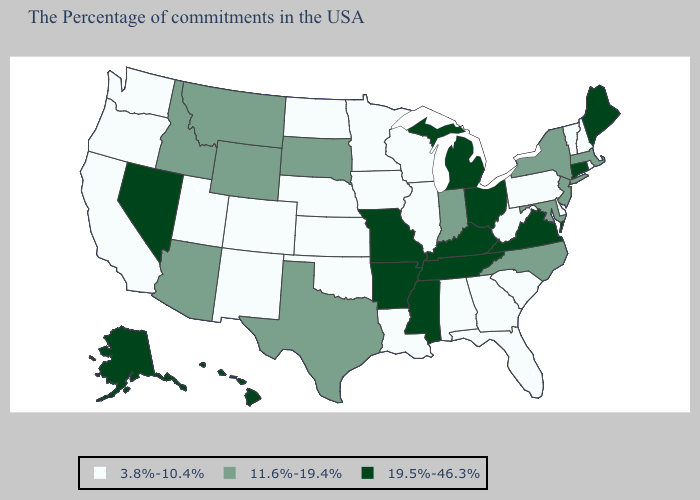Does the first symbol in the legend represent the smallest category?
Concise answer only. Yes. Does South Carolina have the highest value in the USA?
Answer briefly. No. How many symbols are there in the legend?
Keep it brief. 3. What is the highest value in the Northeast ?
Keep it brief. 19.5%-46.3%. Does Michigan have the highest value in the USA?
Answer briefly. Yes. What is the value of Illinois?
Quick response, please. 3.8%-10.4%. Name the states that have a value in the range 19.5%-46.3%?
Short answer required. Maine, Connecticut, Virginia, Ohio, Michigan, Kentucky, Tennessee, Mississippi, Missouri, Arkansas, Nevada, Alaska, Hawaii. How many symbols are there in the legend?
Answer briefly. 3. What is the highest value in the USA?
Concise answer only. 19.5%-46.3%. Name the states that have a value in the range 19.5%-46.3%?
Concise answer only. Maine, Connecticut, Virginia, Ohio, Michigan, Kentucky, Tennessee, Mississippi, Missouri, Arkansas, Nevada, Alaska, Hawaii. Does North Dakota have a lower value than Nebraska?
Keep it brief. No. Which states have the lowest value in the USA?
Quick response, please. Rhode Island, New Hampshire, Vermont, Delaware, Pennsylvania, South Carolina, West Virginia, Florida, Georgia, Alabama, Wisconsin, Illinois, Louisiana, Minnesota, Iowa, Kansas, Nebraska, Oklahoma, North Dakota, Colorado, New Mexico, Utah, California, Washington, Oregon. Among the states that border Colorado , which have the lowest value?
Concise answer only. Kansas, Nebraska, Oklahoma, New Mexico, Utah. What is the value of Oregon?
Give a very brief answer. 3.8%-10.4%. Among the states that border Minnesota , which have the lowest value?
Quick response, please. Wisconsin, Iowa, North Dakota. 